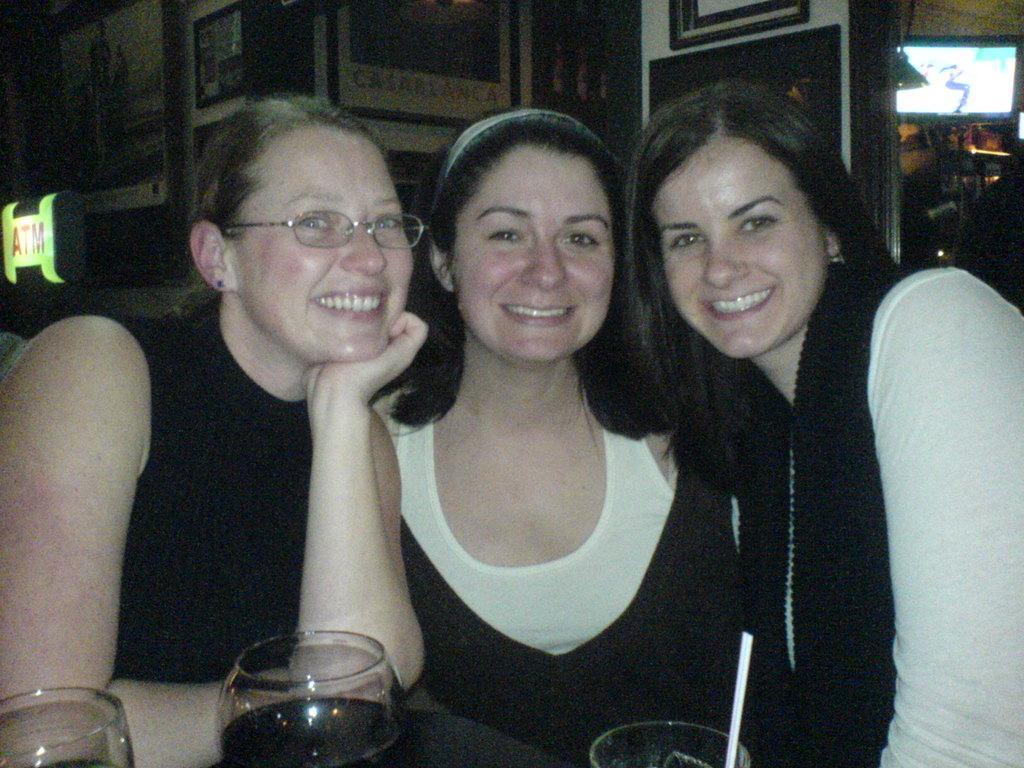Describe this image in one or two sentences. These three people are smiling. In-front of them there are three glasses. Pictures are on the wall. Here we can see board and television. 